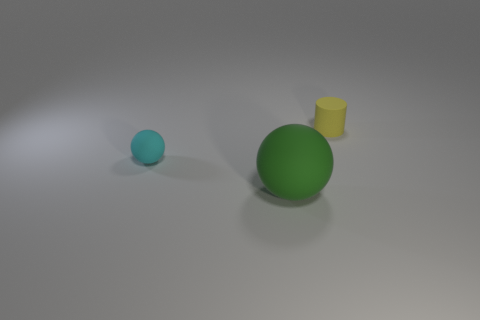Are there any shadows present, and if so, what do they tell us about the light source? Yes, there are shadows present beneath each object, indicating that the light source is coming from the upper left direction, relative to the observer's viewpoint. 